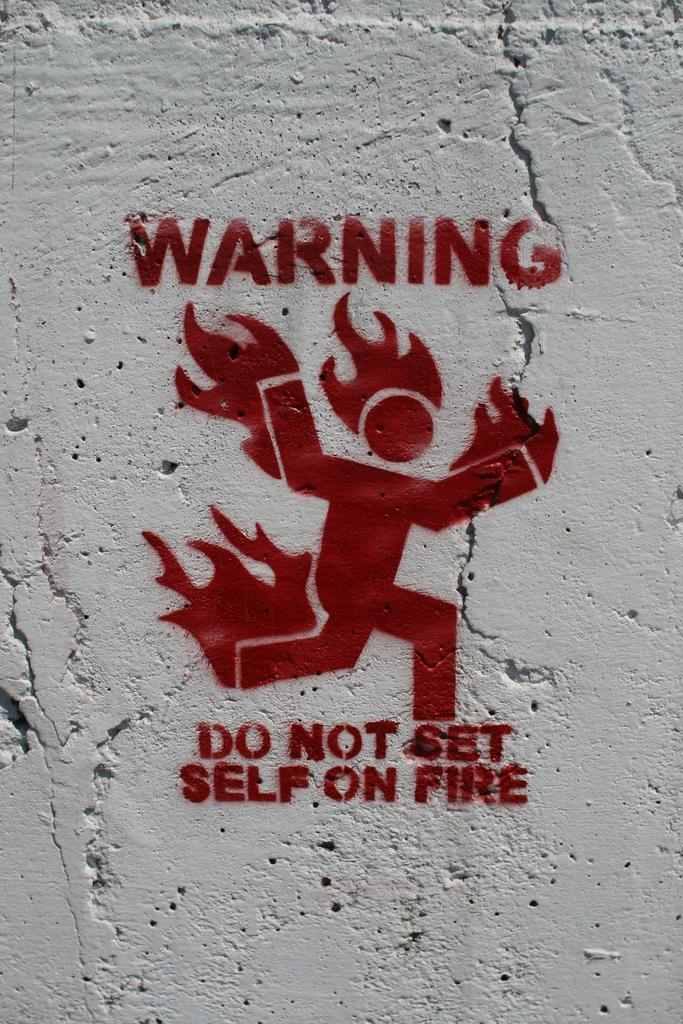What is depicted in the image? There is a painting in the image. What elements can be found within the painting? The painting contains words, a symbol of a person, and a representation of fire. Where is the painting located? The painting is on a wall. What type of stone can be seen in the park near the painting? There is no park or stone present in the image; it only features a painting on a wall. 